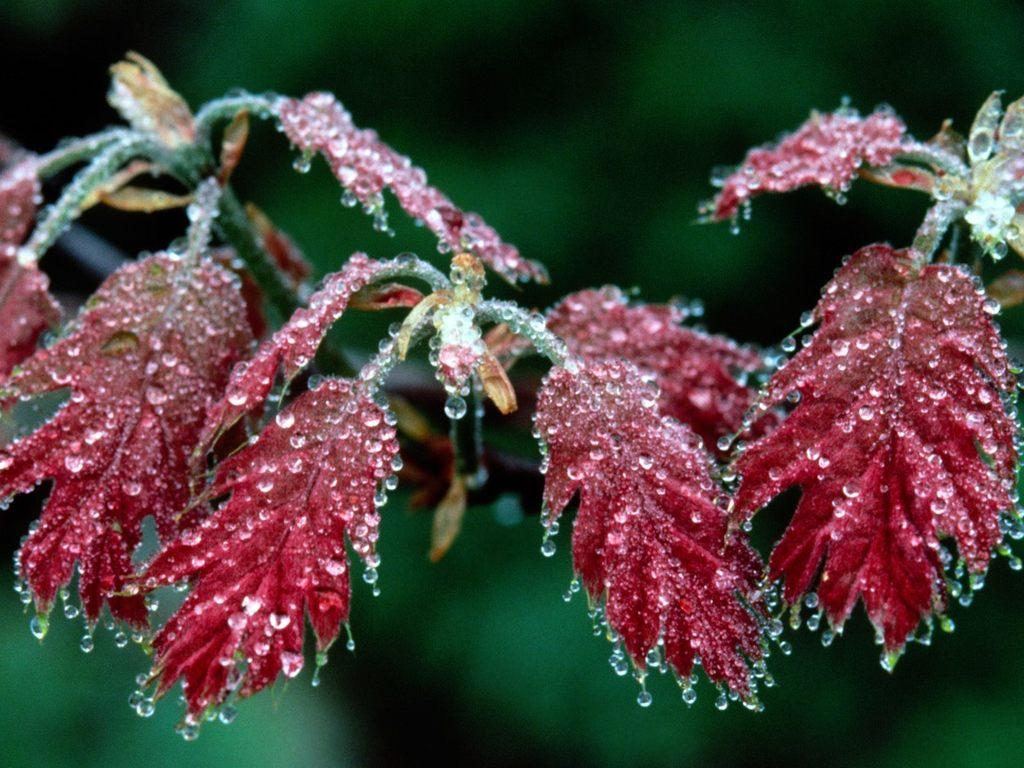What is the main subject of the image? The main subject of the image is a plant stem. Can you describe the condition of the plant leaves? The plant leaves have droplets of water on them. How many pigs are sitting on the committee in the image? There are no pigs or committee present in the image; it features a plant stem with droplets of water on the leaves. 